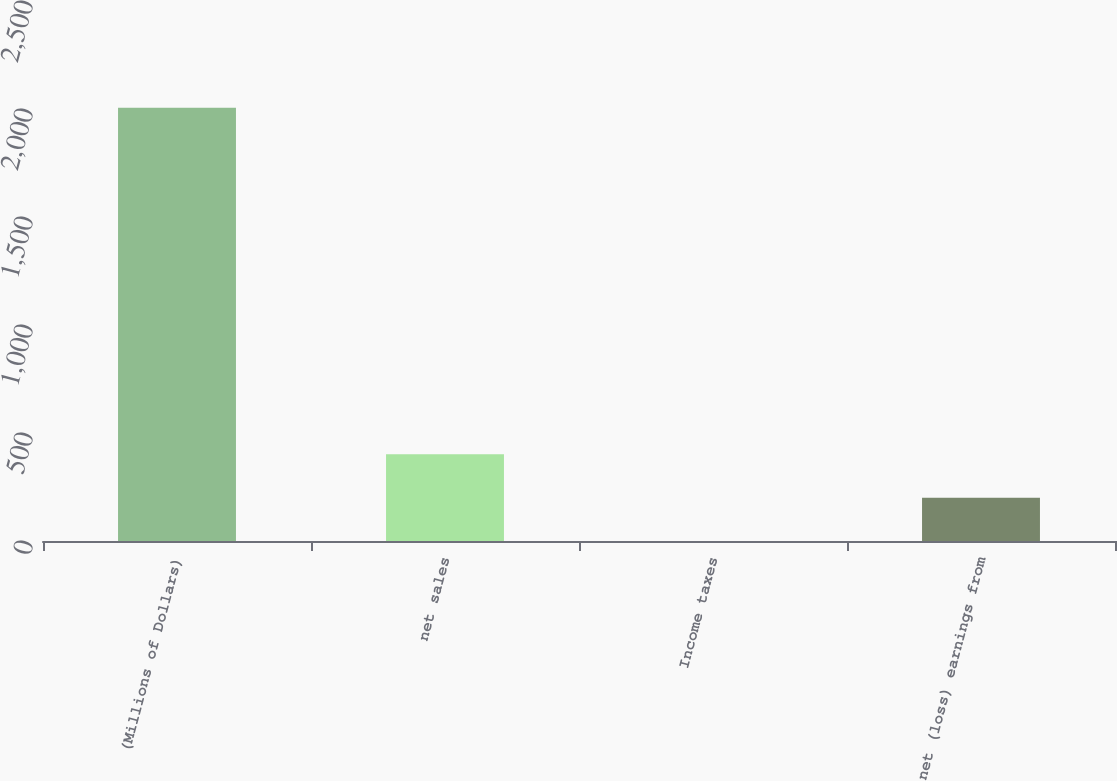<chart> <loc_0><loc_0><loc_500><loc_500><bar_chart><fcel>(Millions of Dollars)<fcel>net sales<fcel>Income taxes<fcel>net (loss) earnings from<nl><fcel>2006<fcel>401.28<fcel>0.1<fcel>200.69<nl></chart> 